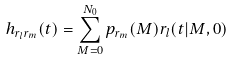<formula> <loc_0><loc_0><loc_500><loc_500>h _ { r _ { l } r _ { m } } ( t ) = \sum _ { M = 0 } ^ { N _ { 0 } } p _ { r _ { m } } ( M ) r _ { l } ( t | M , 0 )</formula> 